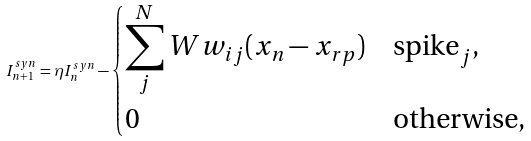<formula> <loc_0><loc_0><loc_500><loc_500>I ^ { s y n } _ { n + 1 } = \eta I ^ { s y n } _ { n } - \begin{dcases} \sum ^ { N } _ { j } W w _ { i j } ( x _ { n } - x _ { r p } ) & \text {spike} _ { j } , \\ 0 & \text {otherwise,} \end{dcases}</formula> 